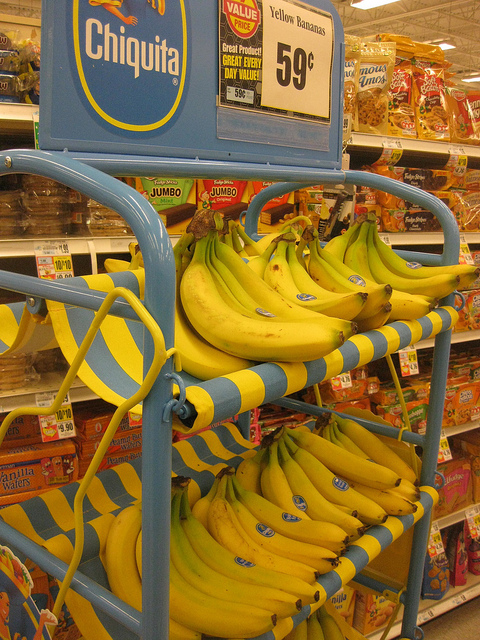Identify the text contained in this image. JUMBO JUMBO anilla Waters Chiquita 9.90 Amos MOUN VALUE DAY EVERY GREAT PRODUCT Great PRICE VALUE Bananas Yellow 59c 